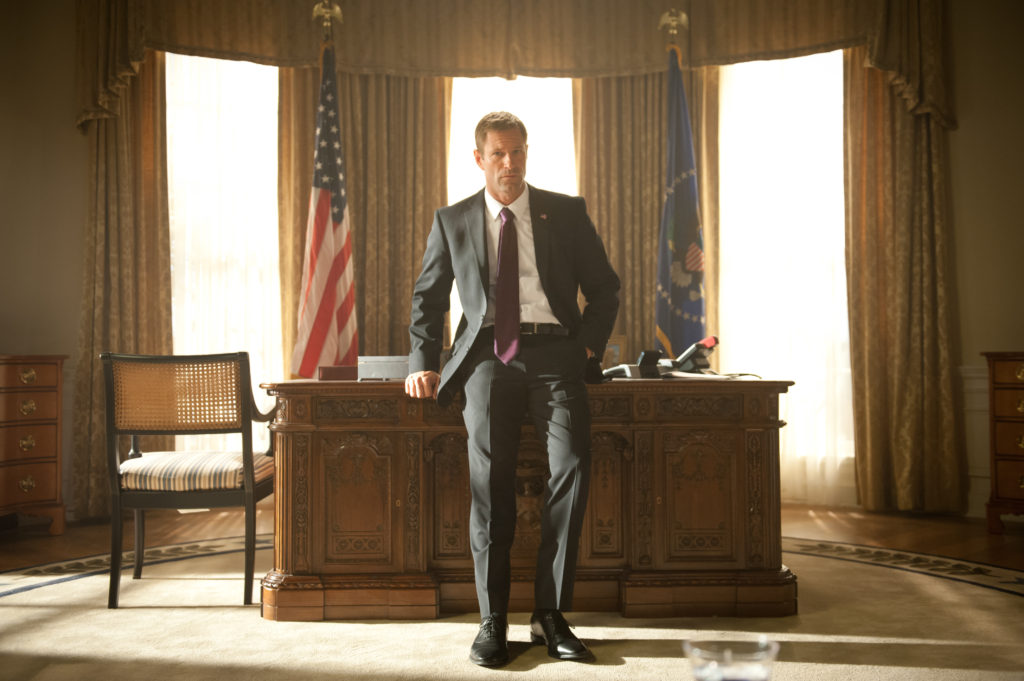Imagine a scenario where the character receives unexpected news. As the character stands pensively by the desk, a secret service agent bursts into the room with a sense of urgency. President Asher, still maintaining his calm demeanor, listens intently to the grave news being delivered. The agent's expression is tense, contrasting sharply with the president's composed reaction. The flags behind him and the grandeur of the room add weight to the moment, highlighting the gravity of the situation. This scenario reveals the depth of leadership required in crisis moments, emphasizing calm under pressure. 